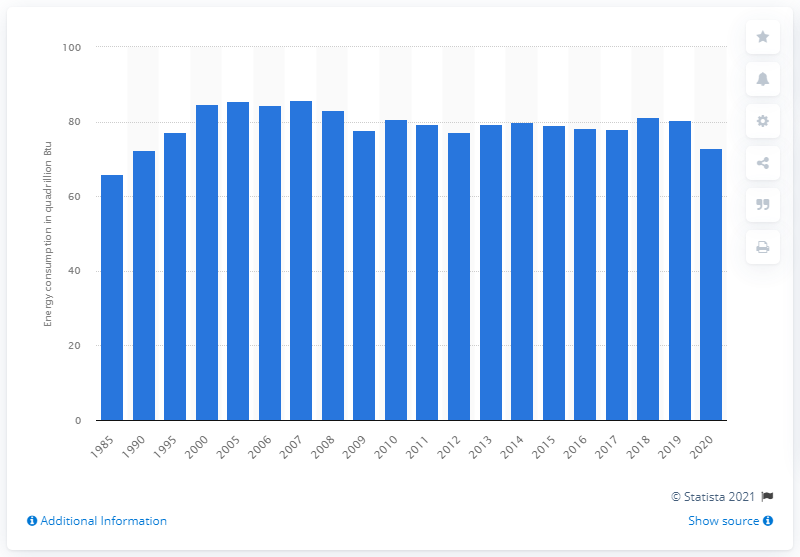Give some essential details in this illustration. In 2020, a total of 72.94 quadrillion British thermal units were consumed. In 2018, a total of 81.27 quadrillion British thermal units were consumed. 